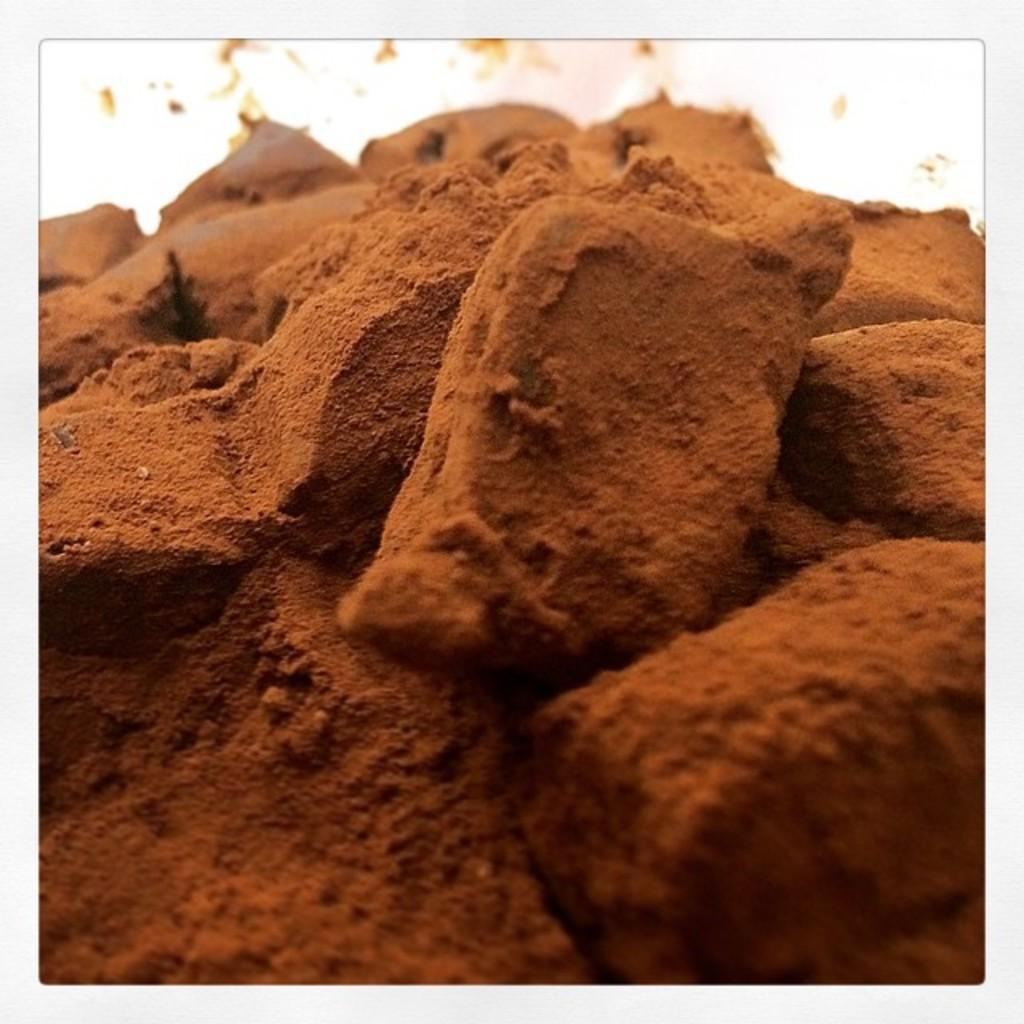Please provide a concise description of this image. There are mud bricks. The background is blurred. 